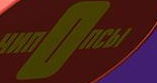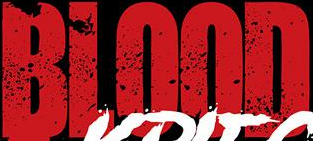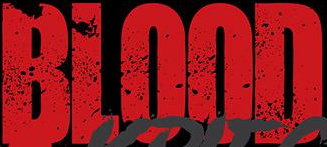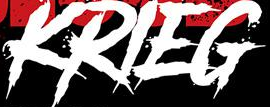Read the text content from these images in order, separated by a semicolon. nOnCbI; BLOOD; BLOOD; KRIEG 